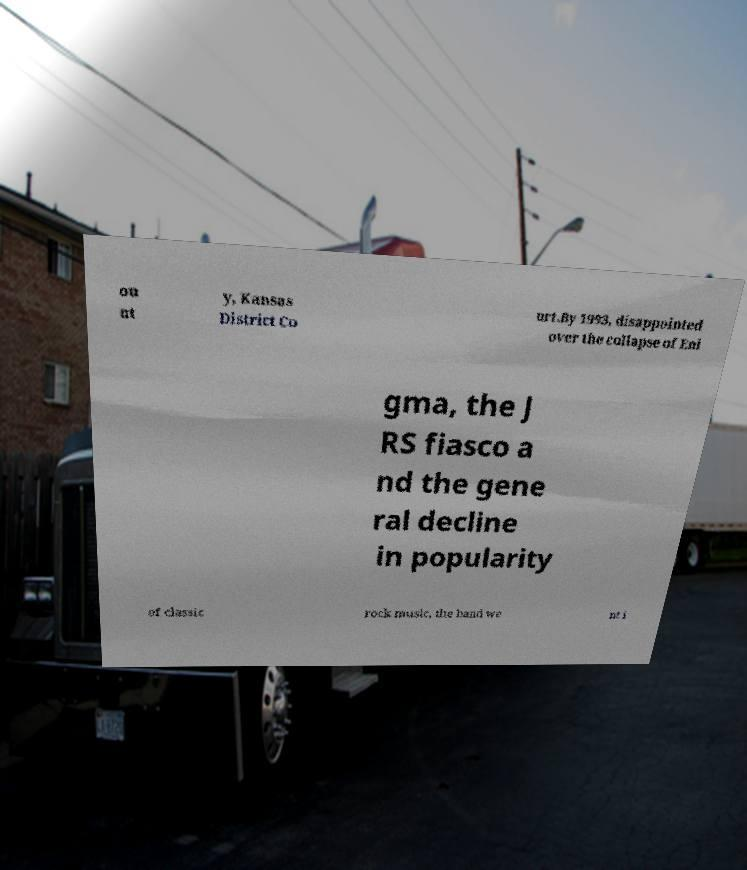Please read and relay the text visible in this image. What does it say? ou nt y, Kansas District Co urt.By 1993, disappointed over the collapse of Eni gma, the J RS fiasco a nd the gene ral decline in popularity of classic rock music, the band we nt i 